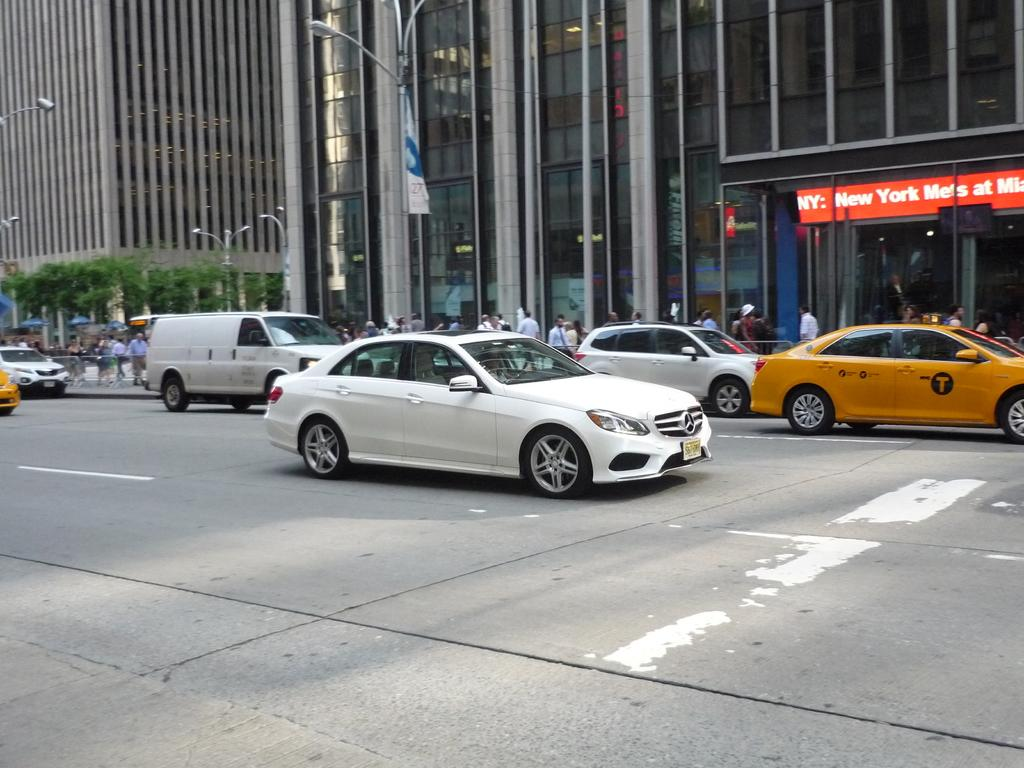<image>
Share a concise interpretation of the image provided. Several cars are on a city street in front of a building above the entrance of which is a sign concerning the New York Mets. 